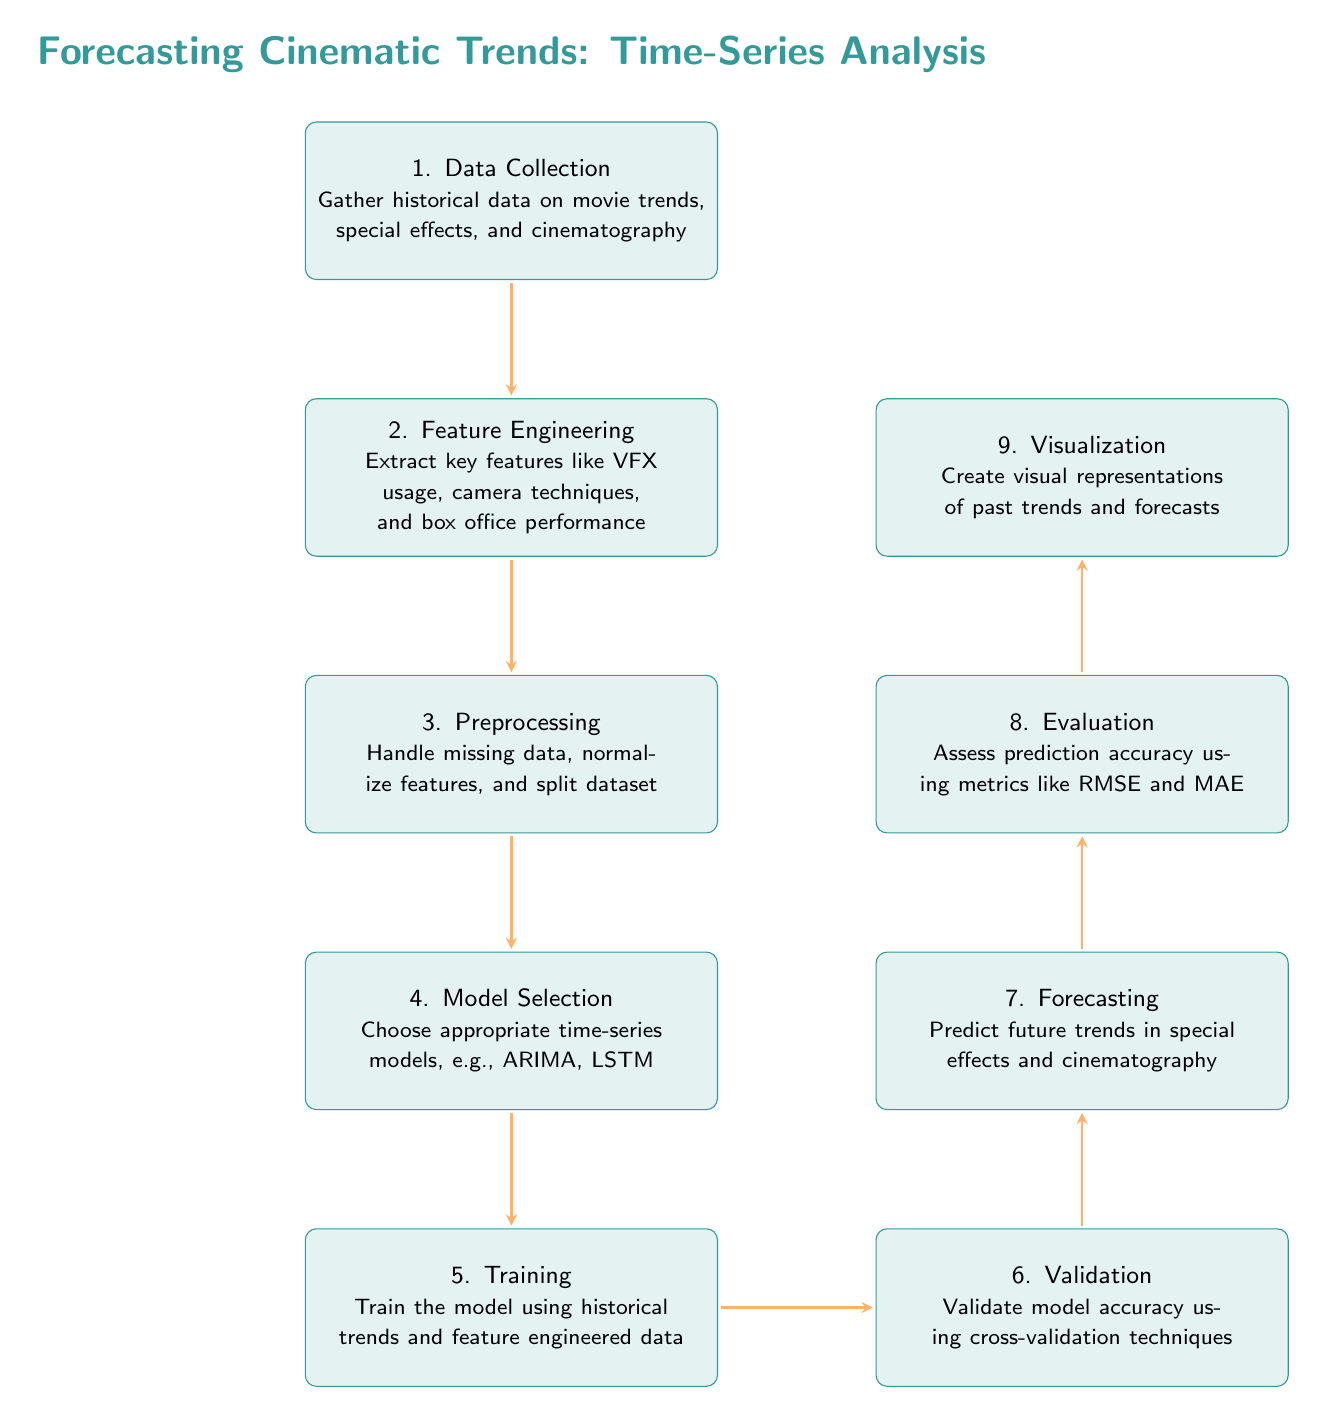What is the first step in the diagram? The first step is "Data Collection," which can be found at the top of the diagram. It involves gathering historical data on movie trends, special effects, and cinematography.
Answer: Data Collection How many nodes are present in the diagram? By counting the boxes in the diagram, there are eight nodes representing different steps in the forecasting process.
Answer: Nine What is the output of the validation step? The validation step leads to the forecasting step, which predicts future trends in special effects and cinematography. The actual output is not explicitly stated, but the direction indicates the next node is "Forecasting."
Answer: Forecasting Which step follows the training step? Following the training step, the next step according to the arrows in the diagram is "Validation." This step evaluates the model's accuracy using various techniques.
Answer: Validation What two metrics are used in the evaluation step? In the evaluation step, the diagram mentions assessing prediction accuracy using RMSE and MAE, which are common metrics for evaluating model performance.
Answer: RMSE and MAE What is the purpose of feature engineering? Feature engineering is about extracting key features like VFX usage, camera techniques, and box office performance, highlighting its role in preparing data for modeling.
Answer: Extract key features What type of models are indicated for selection? The diagram specifies choosing appropriate time-series models like ARIMA and LSTM during the model selection step, indicating a focus on time-series analysis methods.
Answer: ARIMA, LSTM What is the function of the visualization step? The visualization step aims to create visual representations of past trends and forecasts, providing insights into the trends identified in the analysis.
Answer: Create visual representations What does the preprocessing step involve? The preprocessing step entails handling missing data, normalizing features, and splitting the dataset, ensuring the data is prepared for modeling.
Answer: Handle missing data, normalize features, split dataset 